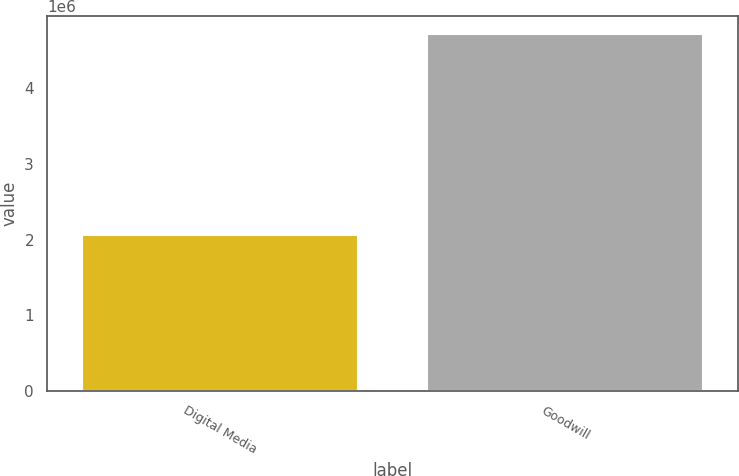Convert chart. <chart><loc_0><loc_0><loc_500><loc_500><bar_chart><fcel>Digital Media<fcel>Goodwill<nl><fcel>2.0574e+06<fcel>4.72196e+06<nl></chart> 